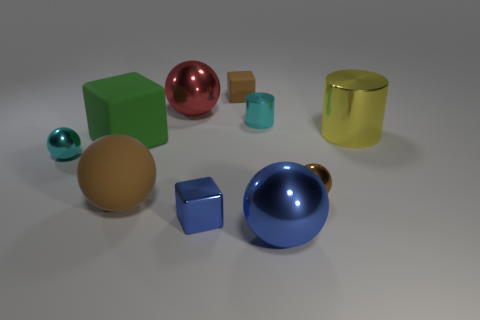Can you describe the arrangement of objects in the image? Certainly! The image features a variety of geometric objects scattered in no discernible pattern across a flat surface. To the left, we see a small teal sphere; forwards a bit is a large brown sphere, with a deep blue cube in front. On the right, there's a pink sphere, a small brown cube, and behind it a large green cube. In the back, there's a gold cylinder, and in the front right, a large blue sphere dominates the forefront.  Are there any repeating patterns or themes in the arrangement? While there's no explicit repeating pattern in the arrangement of the objects, there is a symmetrical balance in terms of color and shape distribution. The variety of objects includes spheres and cubes primarily, offering a subtle theme of geometric diversity. Also, the colors are quite saturated and range from pastel teal to a deep, glossy blue, which provides a vibrant contrast and a theme of color variety. 